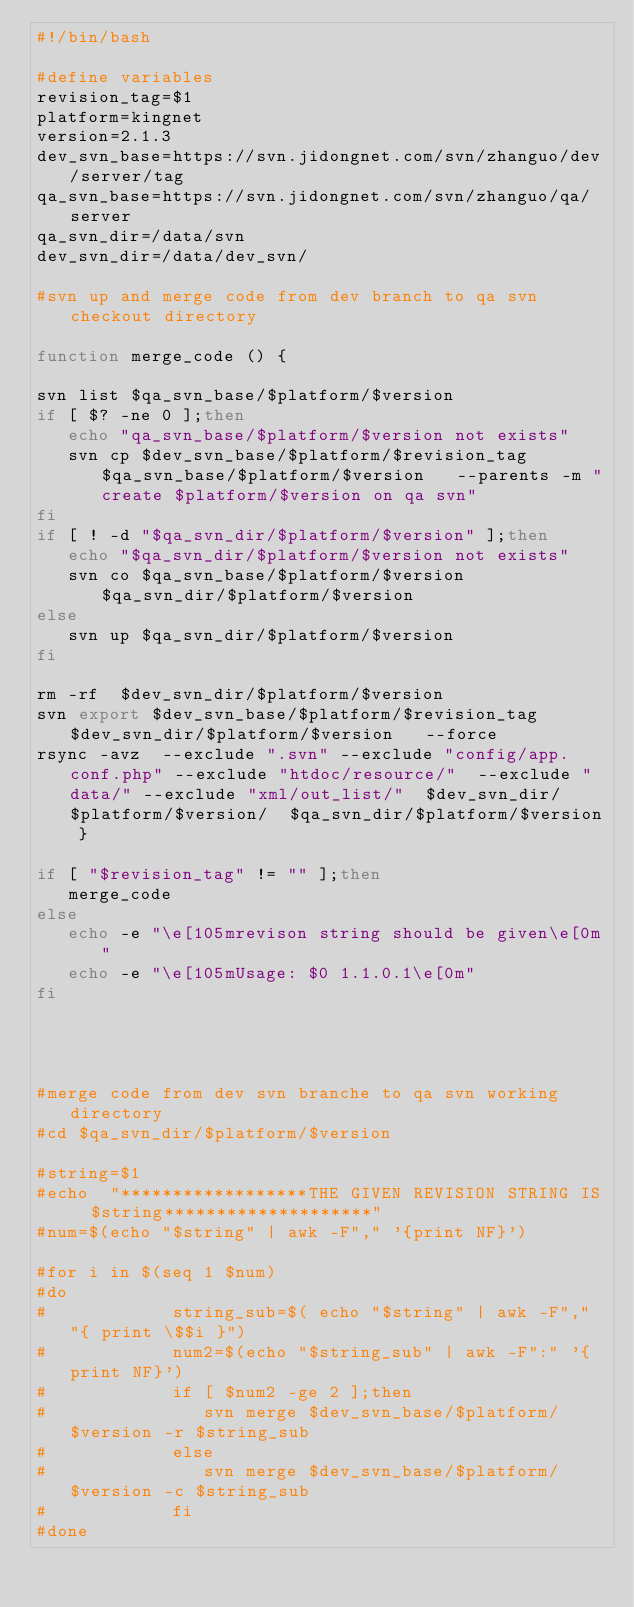<code> <loc_0><loc_0><loc_500><loc_500><_Bash_>#!/bin/bash

#define variables
revision_tag=$1
platform=kingnet
version=2.1.3
dev_svn_base=https://svn.jidongnet.com/svn/zhanguo/dev/server/tag
qa_svn_base=https://svn.jidongnet.com/svn/zhanguo/qa/server
qa_svn_dir=/data/svn
dev_svn_dir=/data/dev_svn/

#svn up and merge code from dev branch to qa svn checkout directory

function merge_code () {

svn list $qa_svn_base/$platform/$version
if [ $? -ne 0 ];then
   echo "qa_svn_base/$platform/$version not exists"
   svn cp $dev_svn_base/$platform/$revision_tag $qa_svn_base/$platform/$version   --parents -m "create $platform/$version on qa svn"
fi
if [ ! -d "$qa_svn_dir/$platform/$version" ];then
   echo "$qa_svn_dir/$platform/$version not exists"
   svn co $qa_svn_base/$platform/$version   $qa_svn_dir/$platform/$version
else
   svn up $qa_svn_dir/$platform/$version
fi

rm -rf  $dev_svn_dir/$platform/$version 	
svn export $dev_svn_base/$platform/$revision_tag   $dev_svn_dir/$platform/$version   --force
rsync -avz  --exclude ".svn" --exclude "config/app.conf.php" --exclude "htdoc/resource/"  --exclude "data/" --exclude "xml/out_list/"  $dev_svn_dir/$platform/$version/  $qa_svn_dir/$platform/$version
    }

if [ "$revision_tag" != "" ];then
   merge_code
else
   echo -e "\e[105mrevison string should be given\e[0m"
   echo -e "\e[105mUsage: $0 1.1.0.1\e[0m"
fi




#merge code from dev svn branche to qa svn working  directory
#cd $qa_svn_dir/$platform/$version

#string=$1
#echo  "******************THE GIVEN REVISION STRING IS  $string********************"
#num=$(echo "$string" | awk -F"," '{print NF}')

#for i in $(seq 1 $num)
#do
#            string_sub=$( echo "$string" | awk -F"," "{ print \$$i }")
#            num2=$(echo "$string_sub" | awk -F":" '{print NF}')
#            if [ $num2 -ge 2 ];then
#               svn merge $dev_svn_base/$platform/$version -r $string_sub
#            else
#               svn merge $dev_svn_base/$platform/$version -c $string_sub
#            fi
#done








</code> 